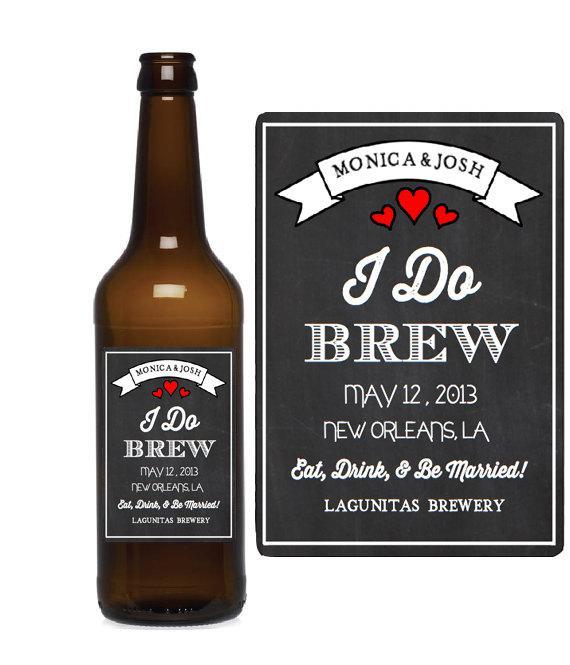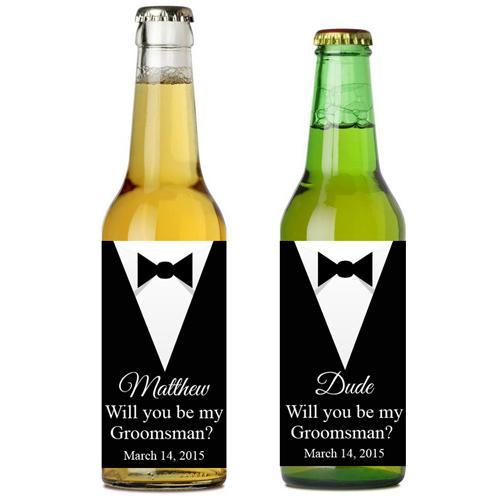The first image is the image on the left, the second image is the image on the right. Analyze the images presented: Is the assertion "An image features exactly four bottles in a row." valid? Answer yes or no. No. 